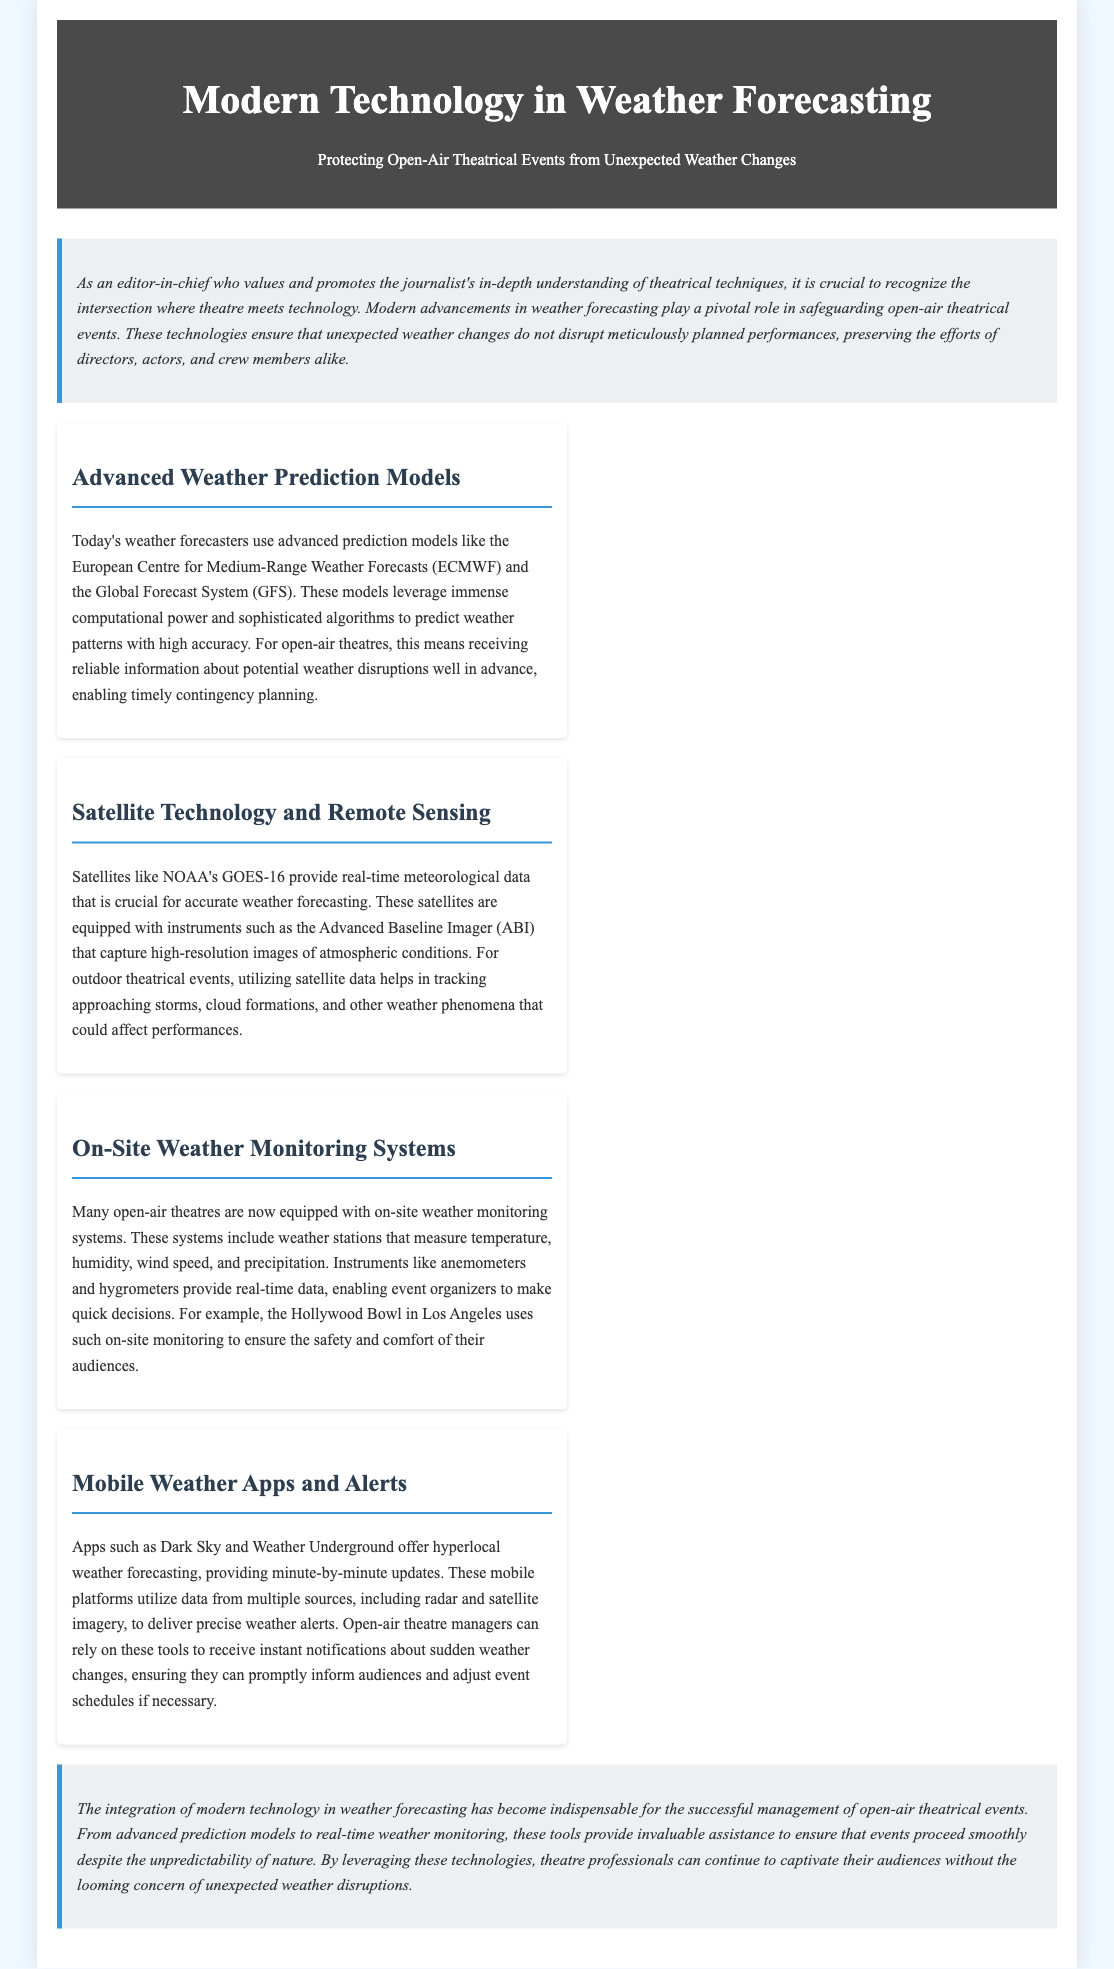What is the title of the report? The title of the report is stated in the header section of the document.
Answer: Modern Technology in Weather Forecasting What technology is used for advanced weather prediction? The document mentions specific models used for weather prediction.
Answer: ECMWF and GFS Which satellite is highlighted for providing real-time meteorological data? The satellite mentioned in the document for real-time data is significant for weather forecasting.
Answer: NOAA's GOES-16 What instrument does the NOAA satellite use for images? The document specifies an instrument that captures images of atmospheric conditions.
Answer: Advanced Baseline Imager (ABI) What is the purpose of on-site weather monitoring systems? The document describes the role of these systems in outdoor theatres.
Answer: Measure weather variables Which mobile app provides minute-by-minute updates? The document includes specific examples of mobile apps for weather alerts.
Answer: Dark Sky How does the Hollywood Bowl manage weather monitoring? The document provides an example of a venue using technology for safety.
Answer: On-site monitoring systems What do mobile weather apps use to deliver precise alerts? The document outlines the sources of data for mobile weather applications.
Answer: Multiple sources What is the overall benefit of modern technology in weather forecasting for theatres? The document concludes with the significance of these technologies for events.
Answer: Successful management 